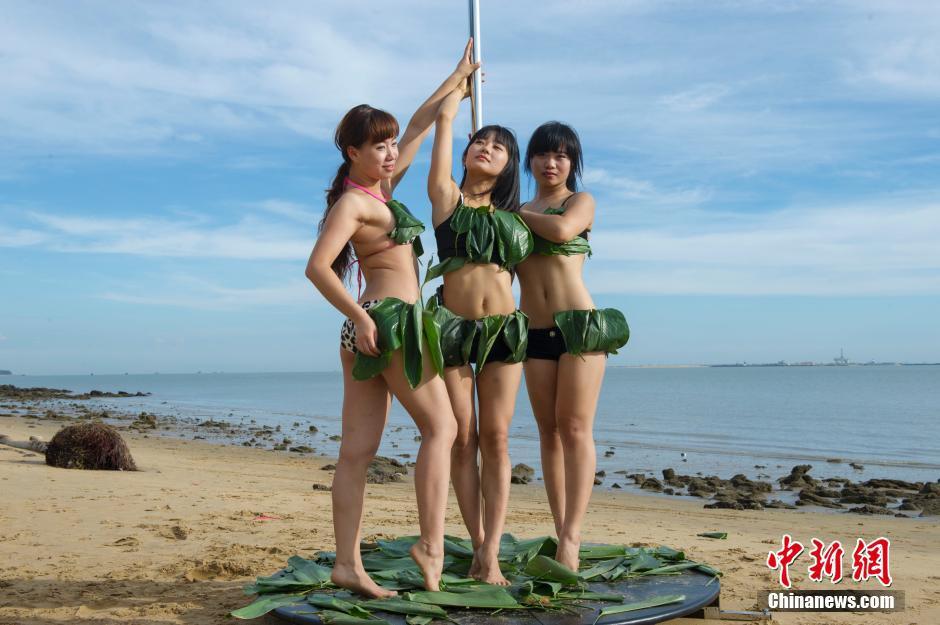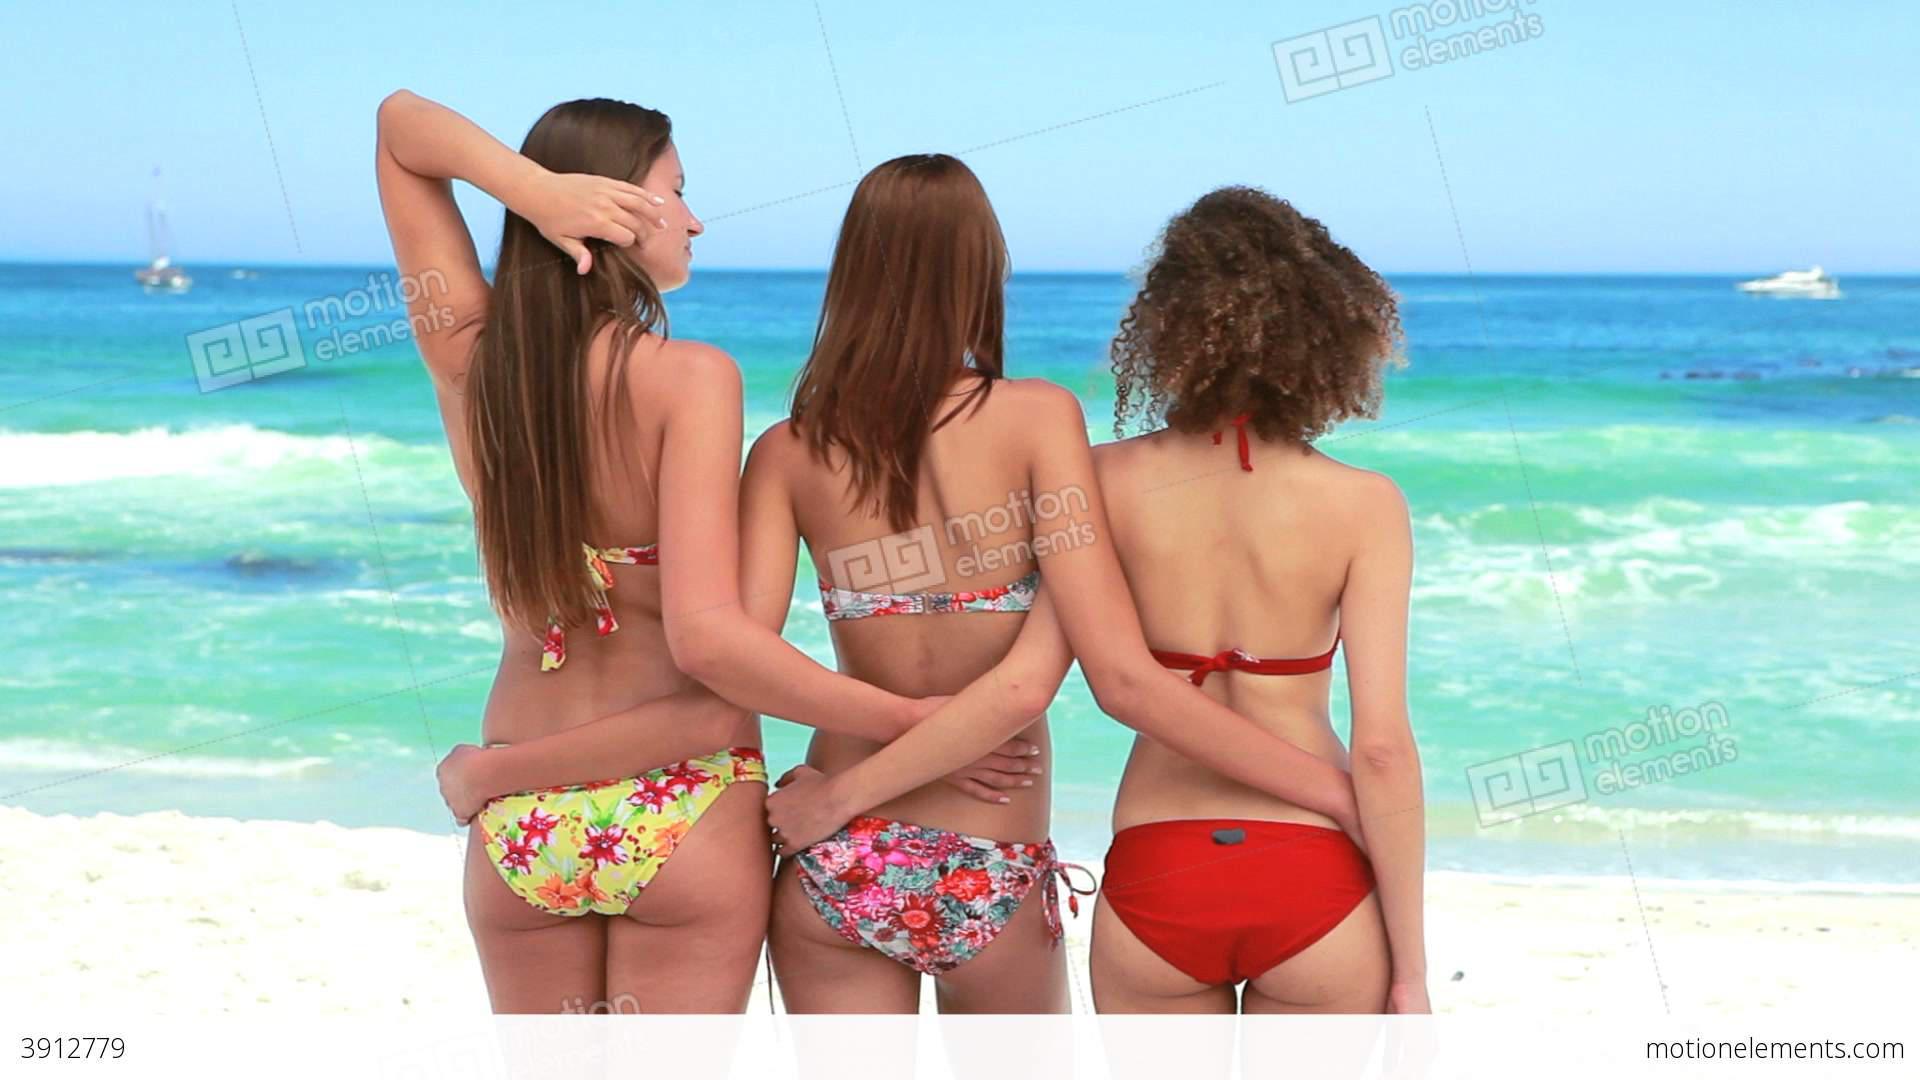The first image is the image on the left, the second image is the image on the right. For the images shown, is this caption "An image shows three bikini models facing the ocean, with backs to the camera." true? Answer yes or no. Yes. The first image is the image on the left, the second image is the image on the right. Given the left and right images, does the statement "Three women are in swimsuits near the water." hold true? Answer yes or no. Yes. 